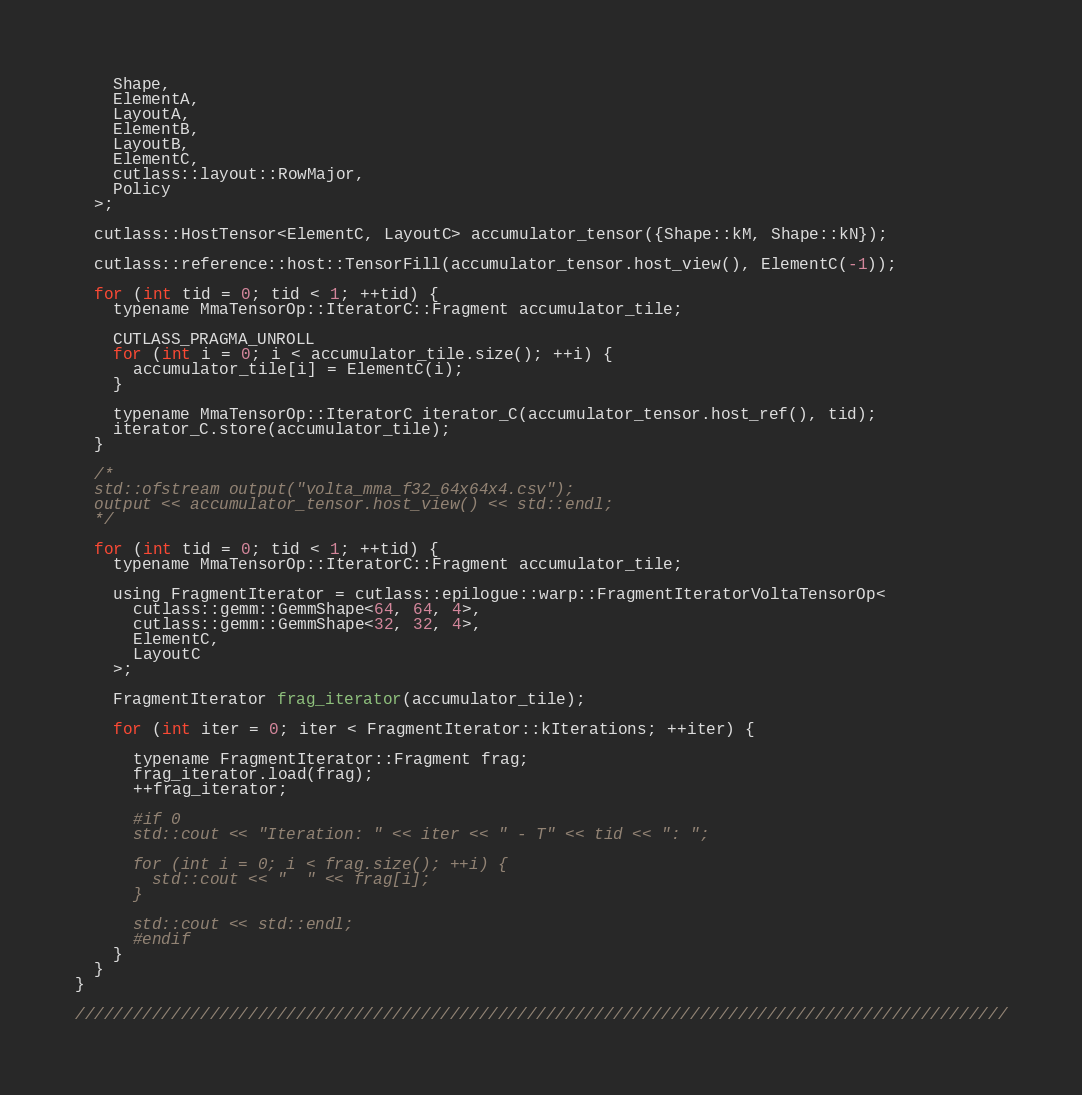<code> <loc_0><loc_0><loc_500><loc_500><_Cuda_>    Shape,
    ElementA,
    LayoutA,
    ElementB,
    LayoutB,
    ElementC,
    cutlass::layout::RowMajor,
    Policy
  >;

  cutlass::HostTensor<ElementC, LayoutC> accumulator_tensor({Shape::kM, Shape::kN});

  cutlass::reference::host::TensorFill(accumulator_tensor.host_view(), ElementC(-1));

  for (int tid = 0; tid < 1; ++tid) {
    typename MmaTensorOp::IteratorC::Fragment accumulator_tile;

    CUTLASS_PRAGMA_UNROLL
    for (int i = 0; i < accumulator_tile.size(); ++i) {
      accumulator_tile[i] = ElementC(i);
    }

    typename MmaTensorOp::IteratorC iterator_C(accumulator_tensor.host_ref(), tid);  
    iterator_C.store(accumulator_tile);
  }

  /*
  std::ofstream output("volta_mma_f32_64x64x4.csv");
  output << accumulator_tensor.host_view() << std::endl;
  */

  for (int tid = 0; tid < 1; ++tid) {
    typename MmaTensorOp::IteratorC::Fragment accumulator_tile;

    using FragmentIterator = cutlass::epilogue::warp::FragmentIteratorVoltaTensorOp<
      cutlass::gemm::GemmShape<64, 64, 4>,
      cutlass::gemm::GemmShape<32, 32, 4>,
      ElementC,
      LayoutC
    >; 
    
    FragmentIterator frag_iterator(accumulator_tile);

    for (int iter = 0; iter < FragmentIterator::kIterations; ++iter) {

      typename FragmentIterator::Fragment frag;
      frag_iterator.load(frag);
      ++frag_iterator;

      #if 0
      std::cout << "Iteration: " << iter << " - T" << tid << ": ";
      
      for (int i = 0; i < frag.size(); ++i) {
        std::cout << "  " << frag[i];
      }

      std::cout << std::endl;
      #endif
    }
  }
}

/////////////////////////////////////////////////////////////////////////////////////////////////
</code> 